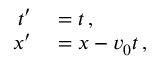Convert formula to latex. <formula><loc_0><loc_0><loc_500><loc_500>\begin{array} { r l } { t ^ { \prime } } & = t \, , } \\ { x ^ { \prime } } & = x - v _ { 0 } t \, , } \end{array}</formula> 